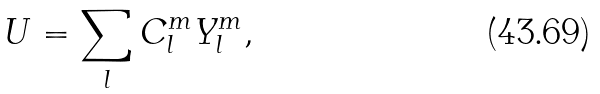Convert formula to latex. <formula><loc_0><loc_0><loc_500><loc_500>U = \sum _ { l } C _ { l } ^ { m } Y _ { l } ^ { m } ,</formula> 